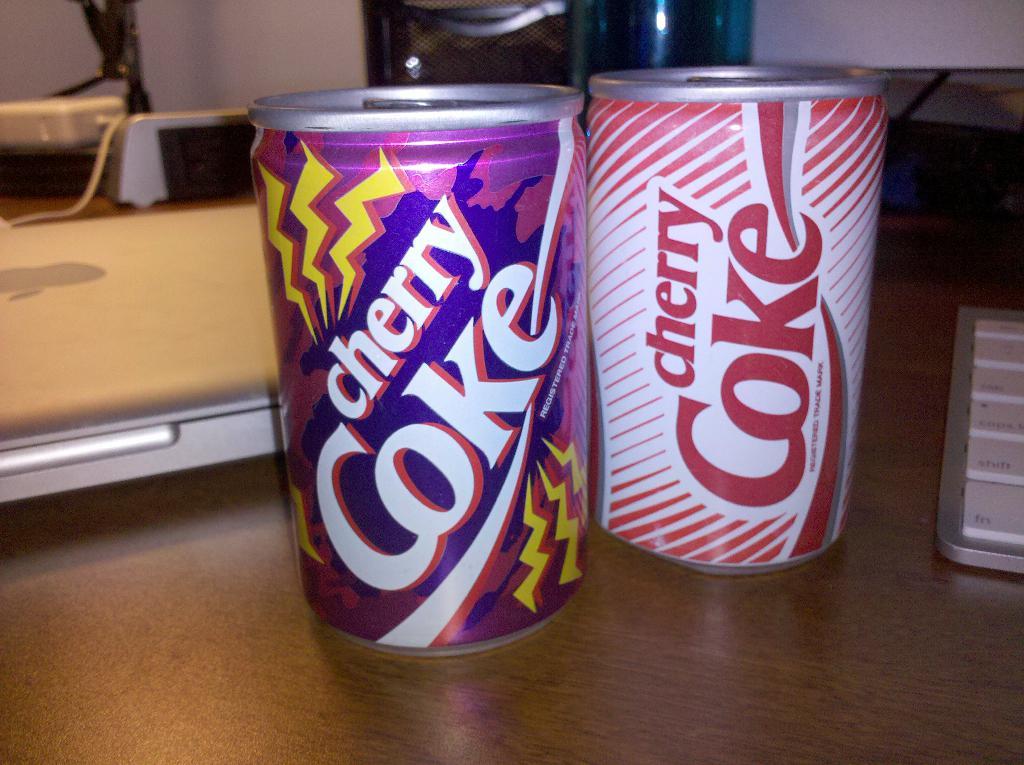What flavor soda is pictured?
Offer a terse response. Cherry coke. 